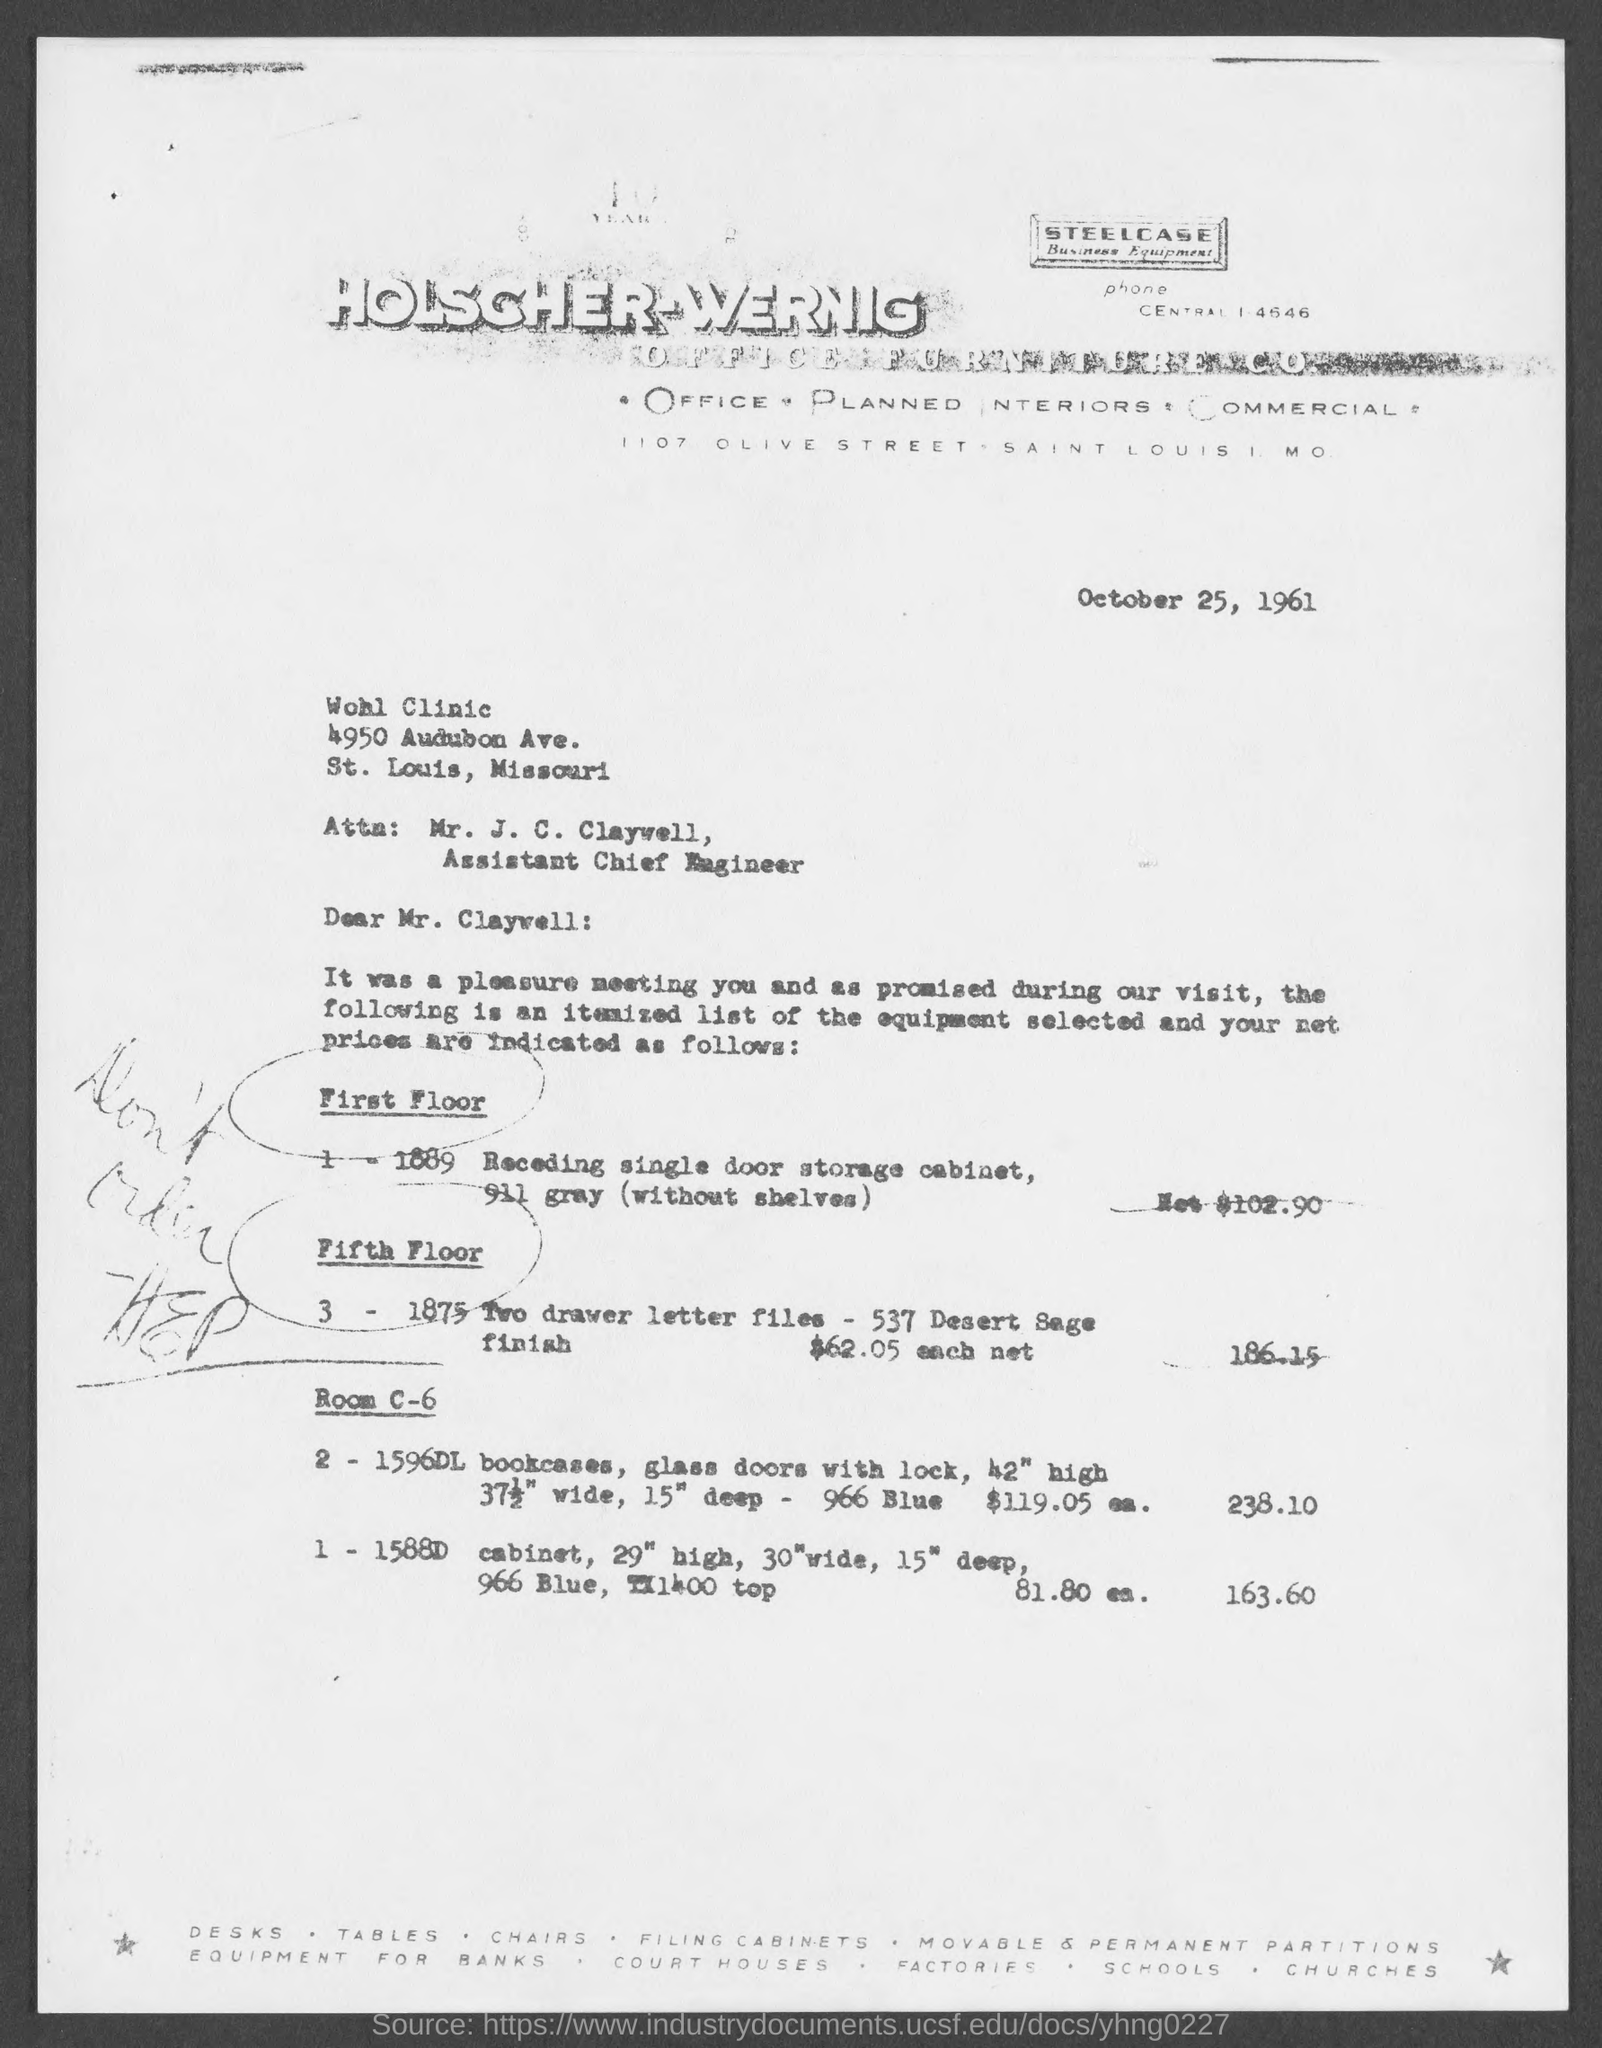What is the date on the document?
Ensure brevity in your answer.  October 25, 1961. To Whom is this letter addressed to?
Your answer should be very brief. Mr. J. C. Claywell. 